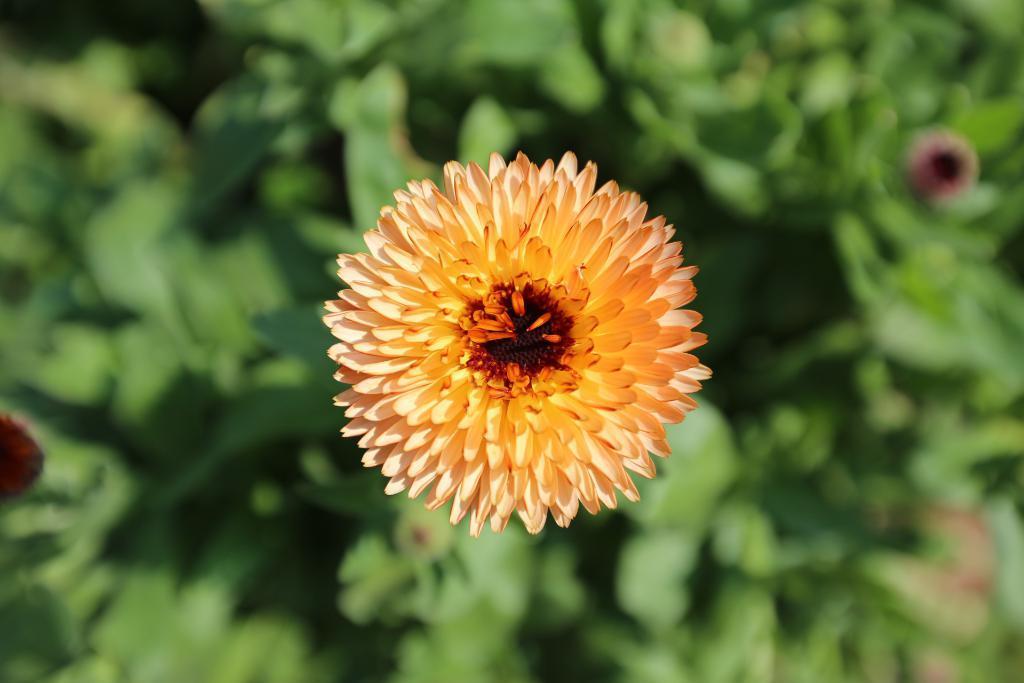Please provide a concise description of this image. In this image in the foreground there is a flower, background is blurry. 